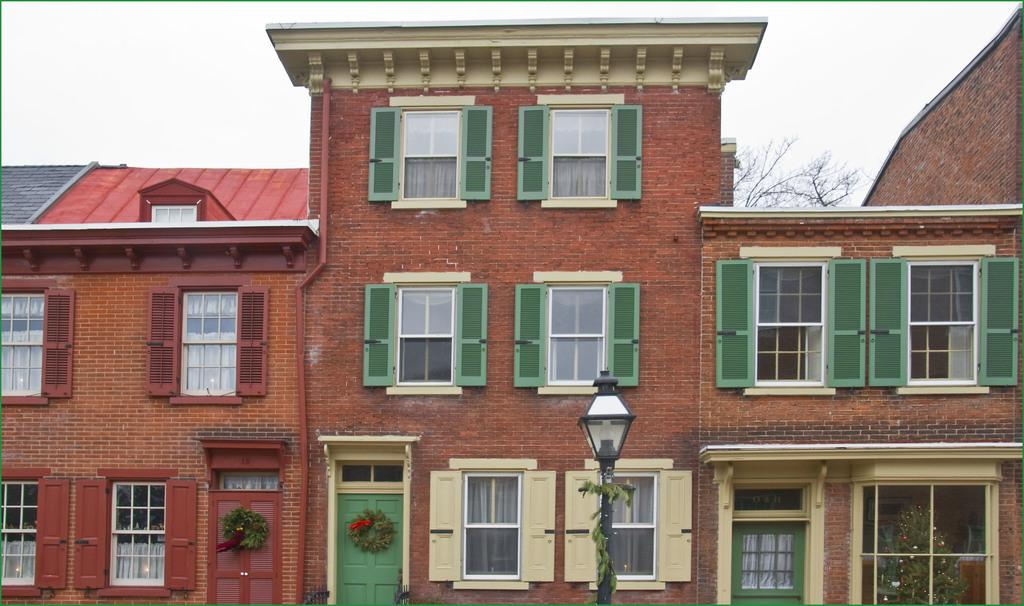What type of structure is in the image? There is a building in the image. What features can be observed on the building? The building has many windows and a door. What else is present in the middle of the image? There is a light pole in the middle of the image. What can be seen above the building? The sky is visible above the building. How many vans are parked in front of the building in the image? There are no vans present in the image. What type of sorting is taking place in the image? There is no sorting activity depicted in the image. 